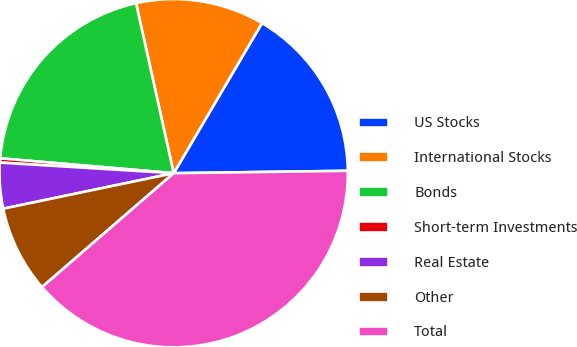<chart> <loc_0><loc_0><loc_500><loc_500><pie_chart><fcel>US Stocks<fcel>International Stocks<fcel>Bonds<fcel>Short-term Investments<fcel>Real Estate<fcel>Other<fcel>Total<nl><fcel>16.32%<fcel>11.93%<fcel>20.17%<fcel>0.39%<fcel>4.24%<fcel>8.08%<fcel>38.87%<nl></chart> 